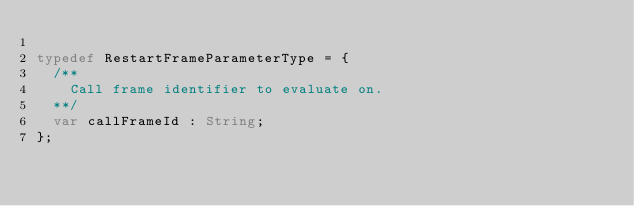<code> <loc_0><loc_0><loc_500><loc_500><_Haxe_>
typedef RestartFrameParameterType = {
	/**
		Call frame identifier to evaluate on.
	**/
	var callFrameId : String;
};</code> 